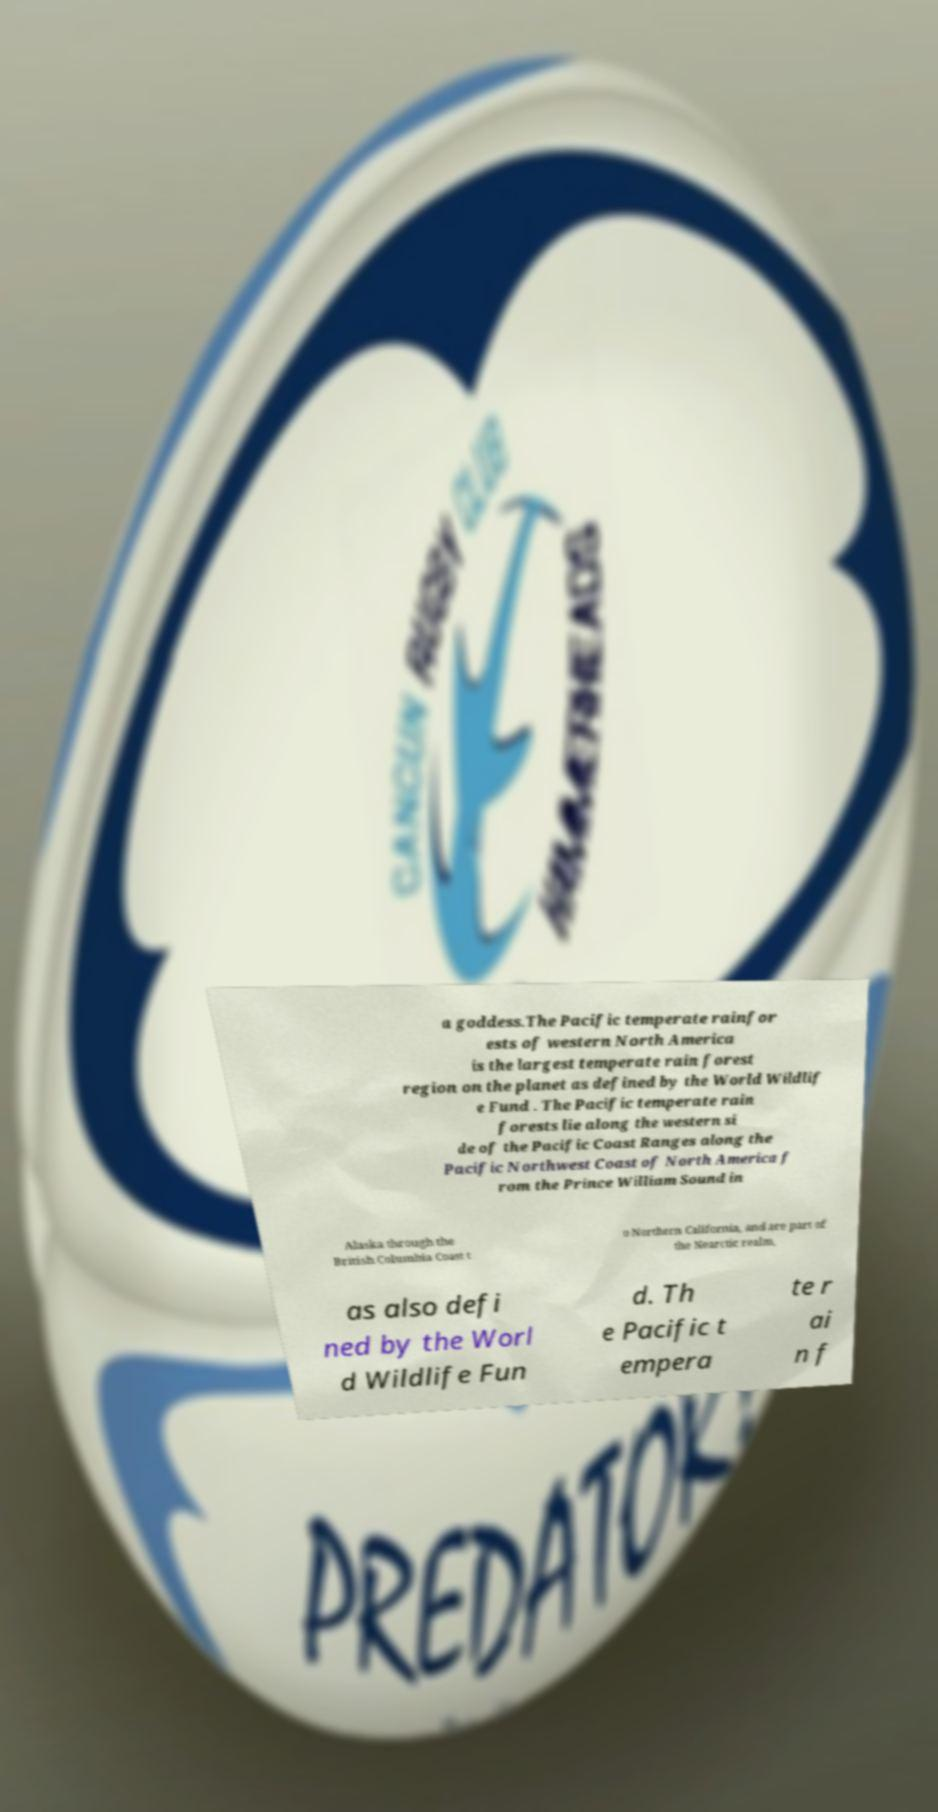Please identify and transcribe the text found in this image. a goddess.The Pacific temperate rainfor ests of western North America is the largest temperate rain forest region on the planet as defined by the World Wildlif e Fund . The Pacific temperate rain forests lie along the western si de of the Pacific Coast Ranges along the Pacific Northwest Coast of North America f rom the Prince William Sound in Alaska through the British Columbia Coast t o Northern California, and are part of the Nearctic realm, as also defi ned by the Worl d Wildlife Fun d. Th e Pacific t empera te r ai n f 